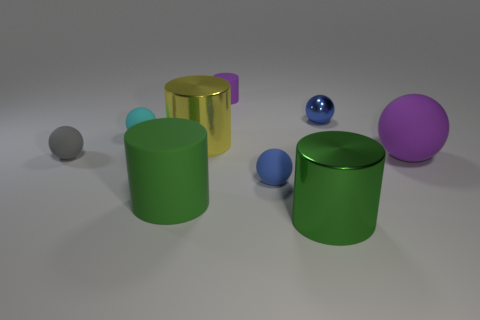Subtract all gray spheres. How many spheres are left? 4 Subtract all gray spheres. Subtract all brown cubes. How many spheres are left? 4 Add 1 big purple rubber balls. How many objects exist? 10 Subtract all balls. How many objects are left? 4 Subtract all large yellow metal spheres. Subtract all small cyan rubber objects. How many objects are left? 8 Add 7 cyan balls. How many cyan balls are left? 8 Add 9 small gray balls. How many small gray balls exist? 10 Subtract 0 green cubes. How many objects are left? 9 